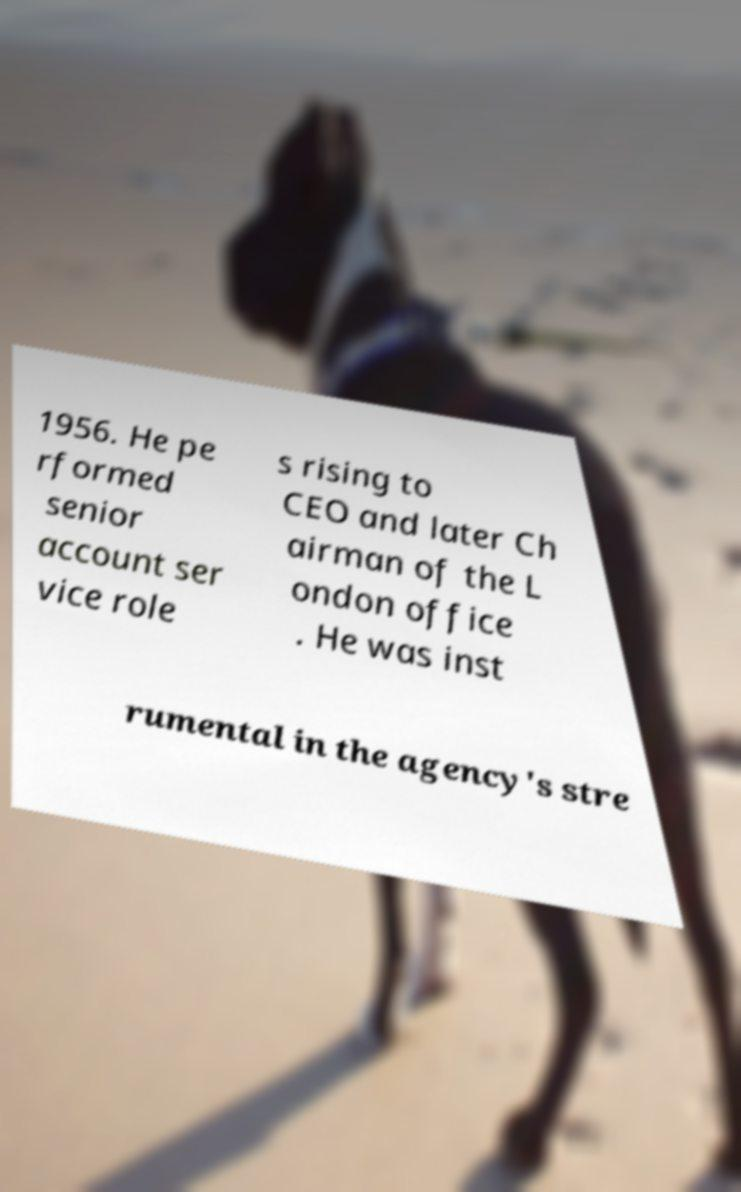Can you accurately transcribe the text from the provided image for me? 1956. He pe rformed senior account ser vice role s rising to CEO and later Ch airman of the L ondon office . He was inst rumental in the agency's stre 